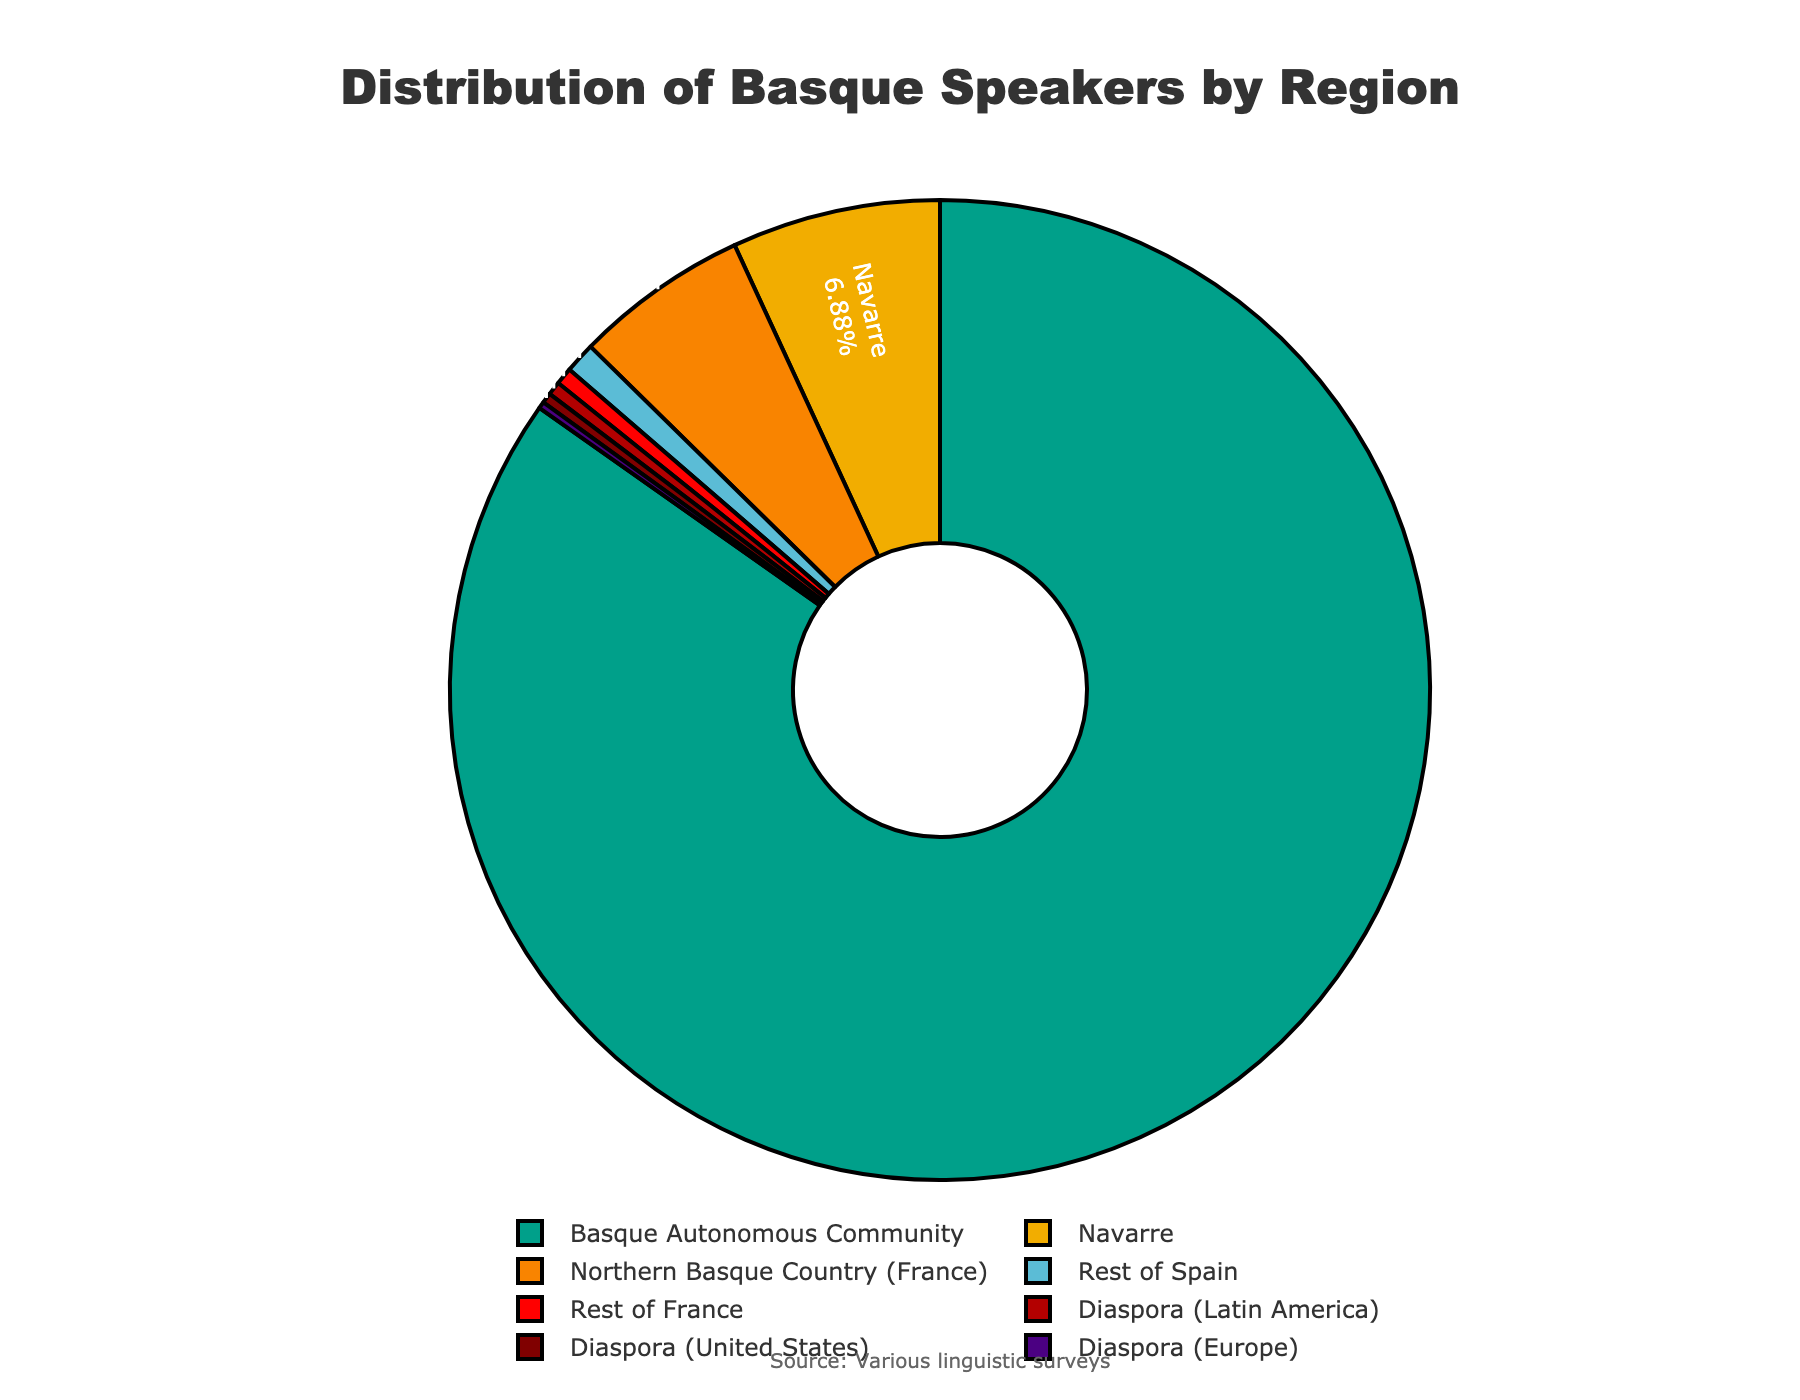Which region has the highest number of Basque speakers? By observing the size of the slices in the pie chart, the Basque Autonomous Community has the largest slice, indicating it has the highest number of Basque speakers.
Answer: Basque Autonomous Community What percentage of Basque speakers live in Navarre? The label and percentage displayed in the pie chart indicate the percentage of Basque speakers in Navarre.
Answer: 7.6% How many more Basque speakers are there in the Basque Autonomous Community than in Navarre? By comparing the values of Basque Autonomous Community (751,000) and Navarre (61,000), subtract Navarre's speakers from Basque Autonomous Community's speakers: 751,000 - 61,000 = 690,000.
Answer: 690,000 What is the total number of Basque speakers in the diaspora regions combined? Sum up the number of Basque speakers in the diaspora regions (Latin America: 4,000, United States: 3,000, Europe: 2,000): 4,000 + 3,000 + 2,000 = 9,000.
Answer: 9,000 Compare the number of Basque speakers in the Northern Basque Country (France) and Rest of Spain. Which has more and by how much? Calculate the difference between Northern Basque Country (51,000) and Rest of Spain (9,000): 51,000 - 9,000 = 42,000.
Answer: Northern Basque Country has 42,000 more What is the percentage of Basque speakers living outside Spain and France? To find the percentage, sum the number of Basque speakers in the diaspora regions (Latin America: 4,000, United States: 3,000, Europe: 2,000 = 9,000), and divide by the total number of speakers, then convert to percentage. Using the provided percentages or approximating the total value of Basque speakers: 4,000 + 3,000 + 2,000 / total = % percentage.
Answer: Approximately 0.7% Which region has the least proportion of Basque speakers and what is its percentage? The region with the smallest slice in the pie chart is Diaspora (Europe) with a corresponding displayed percentage in the pie chart.
Answer: Diaspora (Europe), 0.2% What is the combined percentage of Basque speakers in the Basque Autonomous Community and Navarre? By adding the percentage of Basque Autonomous Community (88.2%) and Navarre (7.6%): 88.2% + 7.6% = 95.8%.
Answer: 95.8% Is there a significant difference between the number of Basque speakers in the Northern Basque Country (France) and the Rest of France? Compare the values of Northern Basque Country (51,000) with Rest of France (5,000) to see the difference: 51,000 - 5,000 = 46,000, which is significant.
Answer: Yes, 46,000 